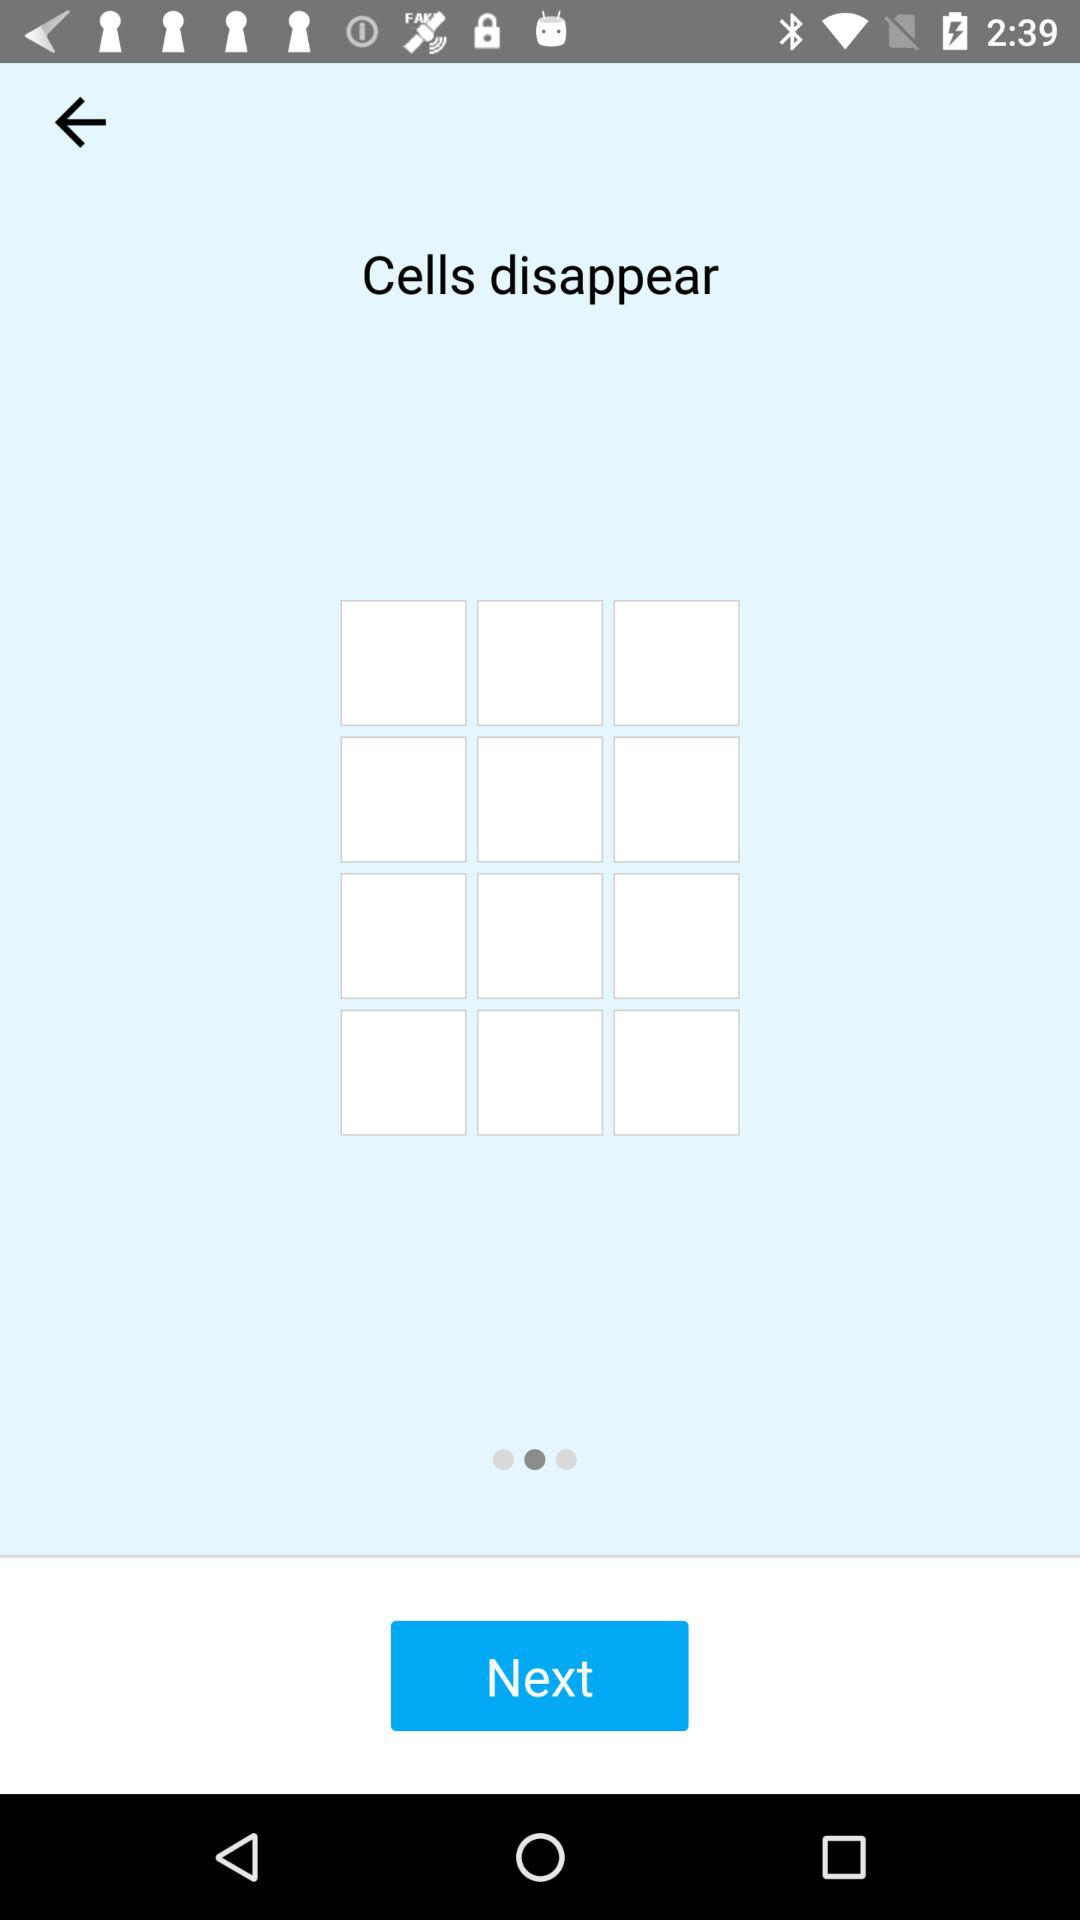What is the name of the application? The name of the application is "Cells disappear". 